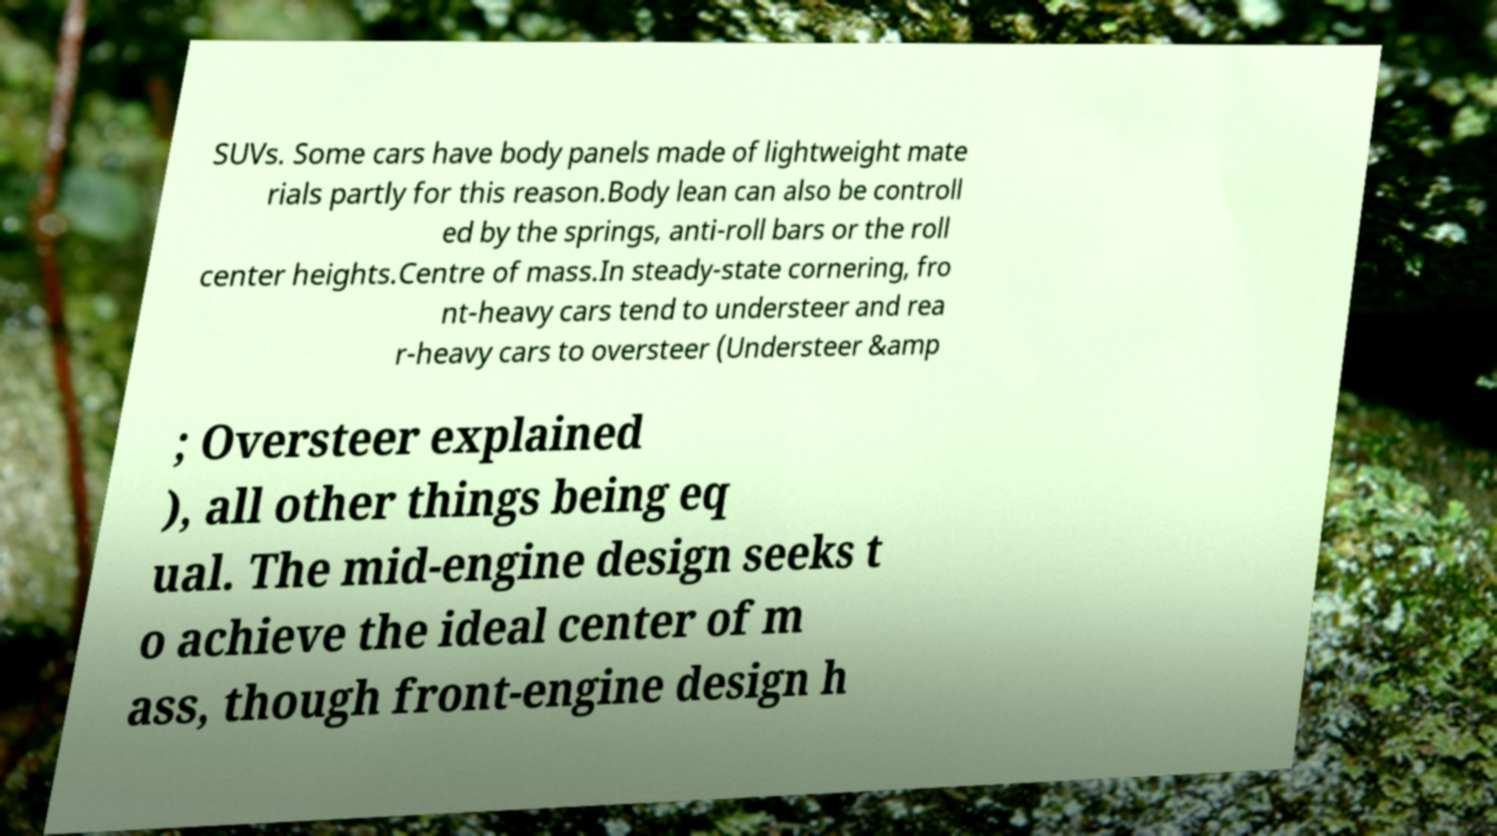Could you assist in decoding the text presented in this image and type it out clearly? SUVs. Some cars have body panels made of lightweight mate rials partly for this reason.Body lean can also be controll ed by the springs, anti-roll bars or the roll center heights.Centre of mass.In steady-state cornering, fro nt-heavy cars tend to understeer and rea r-heavy cars to oversteer (Understeer &amp ; Oversteer explained ), all other things being eq ual. The mid-engine design seeks t o achieve the ideal center of m ass, though front-engine design h 